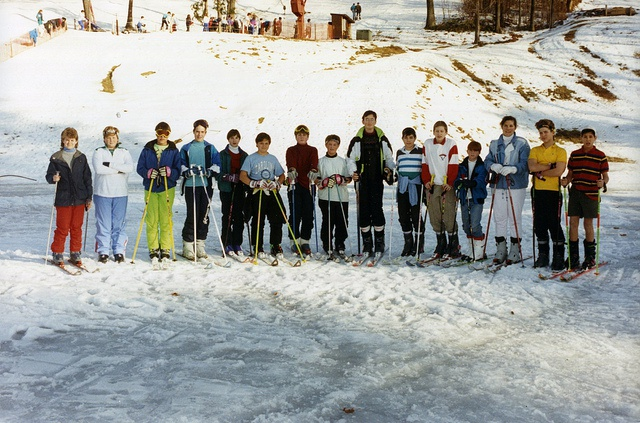Describe the objects in this image and their specific colors. I can see people in lightgray, black, ivory, darkgray, and gray tones, people in lightgray, black, brown, darkgray, and gray tones, people in lightgray, darkgray, black, gray, and navy tones, people in lightgray, olive, black, and navy tones, and people in lightgray, black, darkgray, gray, and olive tones in this image. 